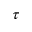<formula> <loc_0><loc_0><loc_500><loc_500>\tau</formula> 